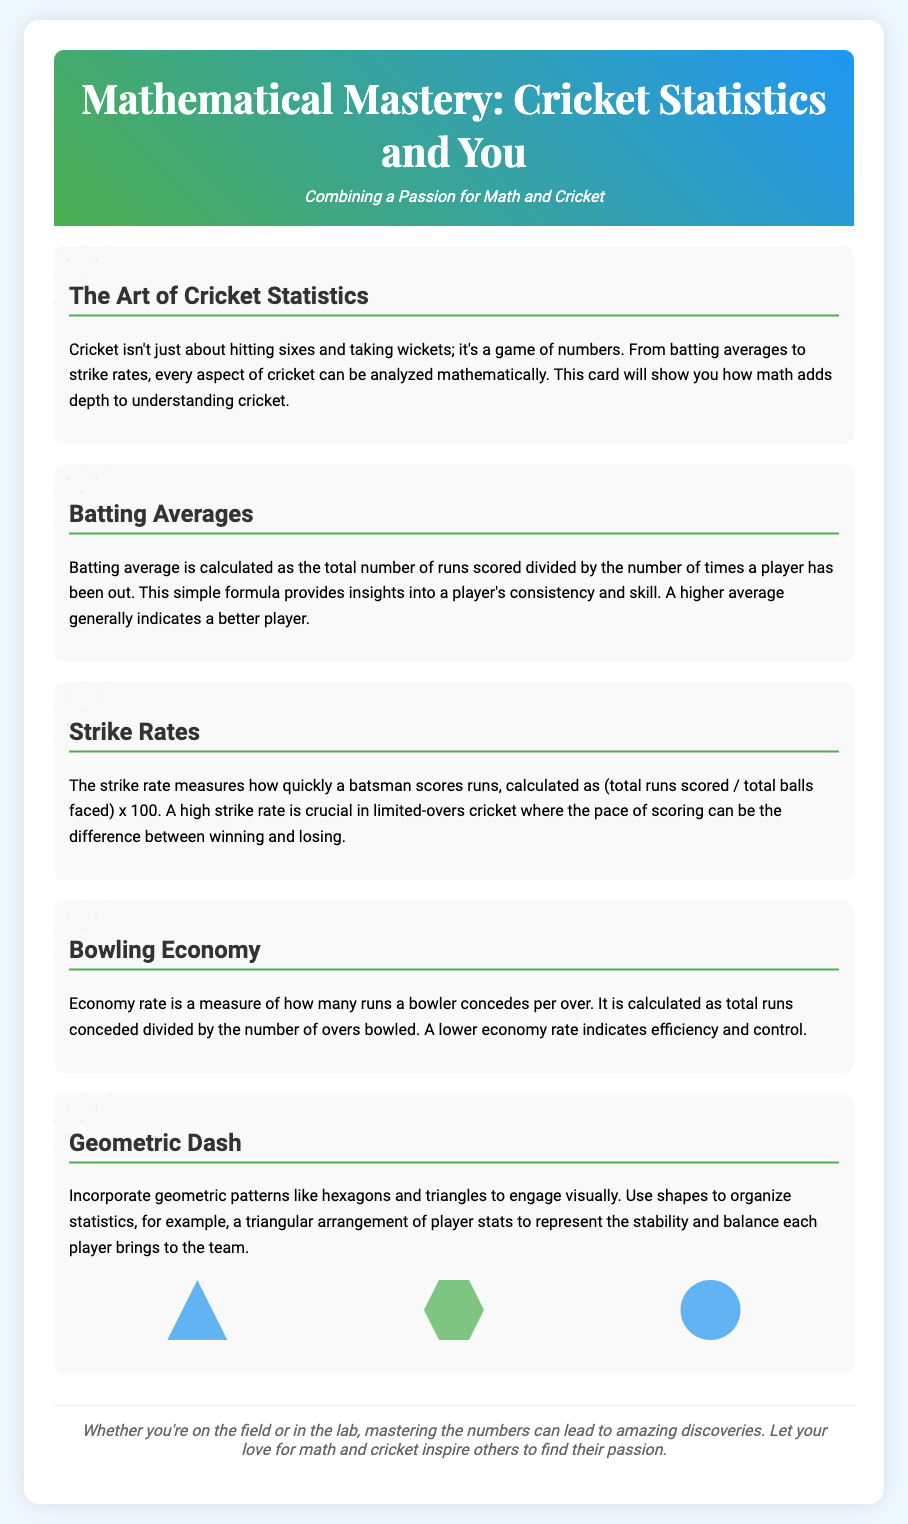What is the title of the card? The title of the card is located in the header section at the top of the document.
Answer: Mathematical Mastery: Cricket Statistics and You What shapes are included in the geometric dash? The document lists specific geometric shapes used in the visual design of the card.
Answer: triangle, hexagon, circle How is the batting average calculated? The document provides a formula for calculating batting averages in the corresponding section.
Answer: Total runs scored divided by the number of times a player has been out What does a high strike rate indicate? The section on strike rates suggests an implication of having a high strike rate.
Answer: Crucial scoring pace What does a lower economy rate indicate? The document explains the significance of a bowler's economy rate in their performance.
Answer: Efficiency and control What color is the header gradient? The card mentions colors in the header background that create a visual impact.
Answer: Green, blue What is the primary theme of the card? The introduction of the card outlines the main focus of its content.
Answer: Combining math and cricket What type of patterns are incorporated visually? The section describing visual elements references specific types of patterns.
Answer: Geometric patterns 